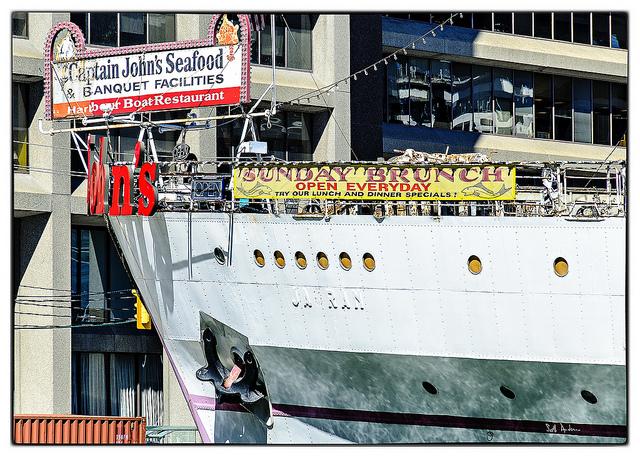What kind of building is the restaurant in?
Quick response, please. Boat. What is the name of the restaurant?
Give a very brief answer. Captain john's seafood. Is Captain John a person?
Concise answer only. Yes. 